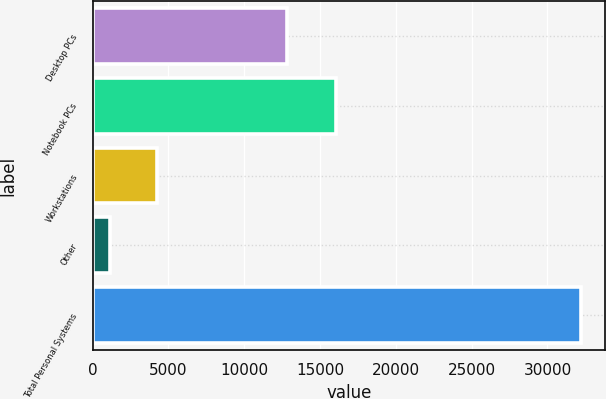<chart> <loc_0><loc_0><loc_500><loc_500><bar_chart><fcel>Desktop PCs<fcel>Notebook PCs<fcel>Workstations<fcel>Other<fcel>Total Personal Systems<nl><fcel>12844<fcel>16029<fcel>4261<fcel>1159<fcel>32179<nl></chart> 